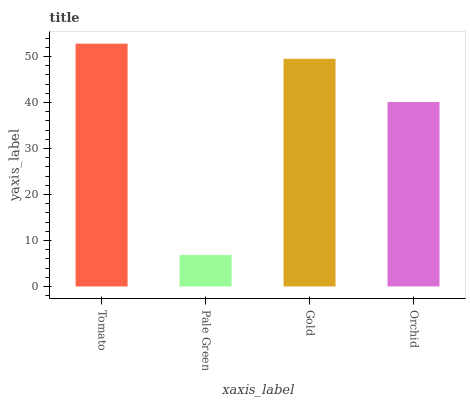Is Pale Green the minimum?
Answer yes or no. Yes. Is Tomato the maximum?
Answer yes or no. Yes. Is Gold the minimum?
Answer yes or no. No. Is Gold the maximum?
Answer yes or no. No. Is Gold greater than Pale Green?
Answer yes or no. Yes. Is Pale Green less than Gold?
Answer yes or no. Yes. Is Pale Green greater than Gold?
Answer yes or no. No. Is Gold less than Pale Green?
Answer yes or no. No. Is Gold the high median?
Answer yes or no. Yes. Is Orchid the low median?
Answer yes or no. Yes. Is Tomato the high median?
Answer yes or no. No. Is Gold the low median?
Answer yes or no. No. 